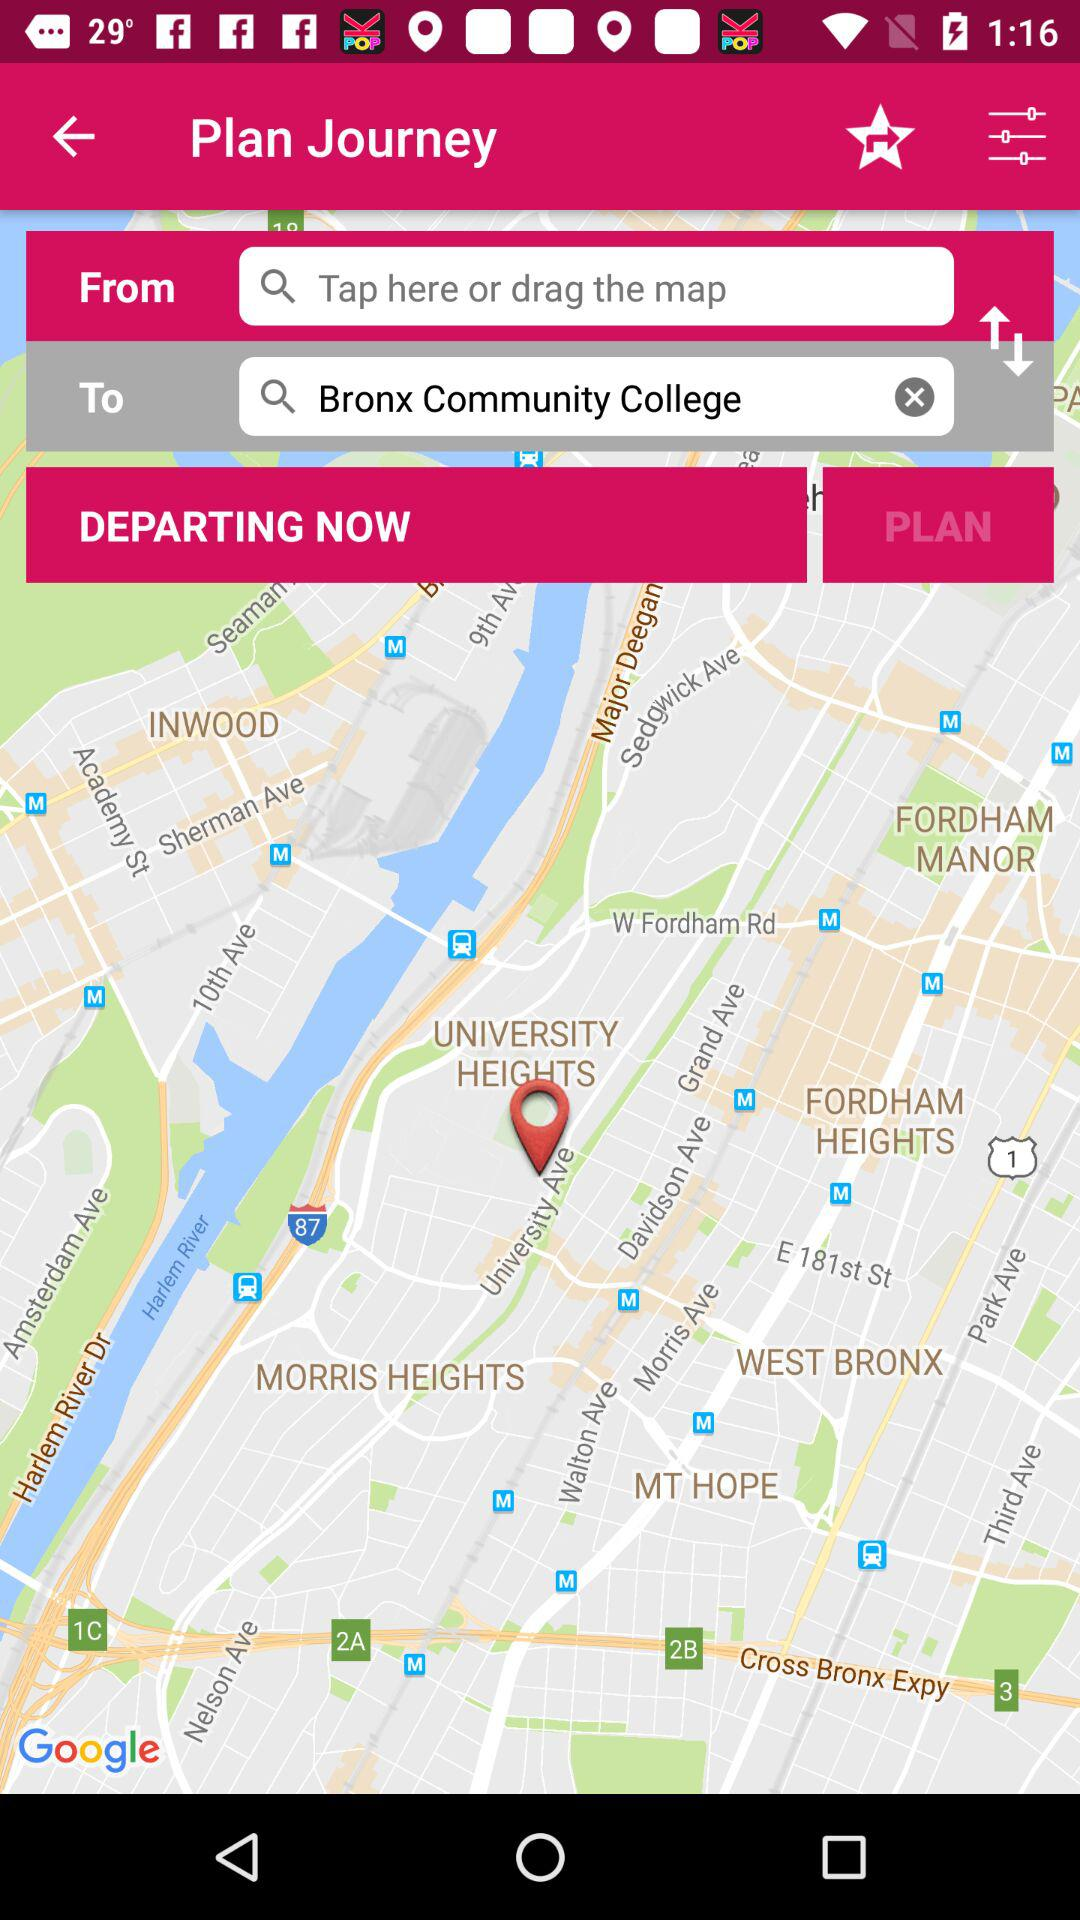What is the arrival location? The arrival location is Bronx Community College. 